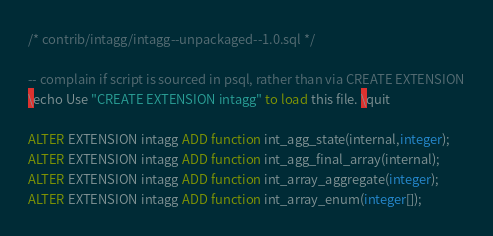Convert code to text. <code><loc_0><loc_0><loc_500><loc_500><_SQL_>/* contrib/intagg/intagg--unpackaged--1.0.sql */

-- complain if script is sourced in psql, rather than via CREATE EXTENSION
\echo Use "CREATE EXTENSION intagg" to load this file. \quit

ALTER EXTENSION intagg ADD function int_agg_state(internal,integer);
ALTER EXTENSION intagg ADD function int_agg_final_array(internal);
ALTER EXTENSION intagg ADD function int_array_aggregate(integer);
ALTER EXTENSION intagg ADD function int_array_enum(integer[]);
</code> 